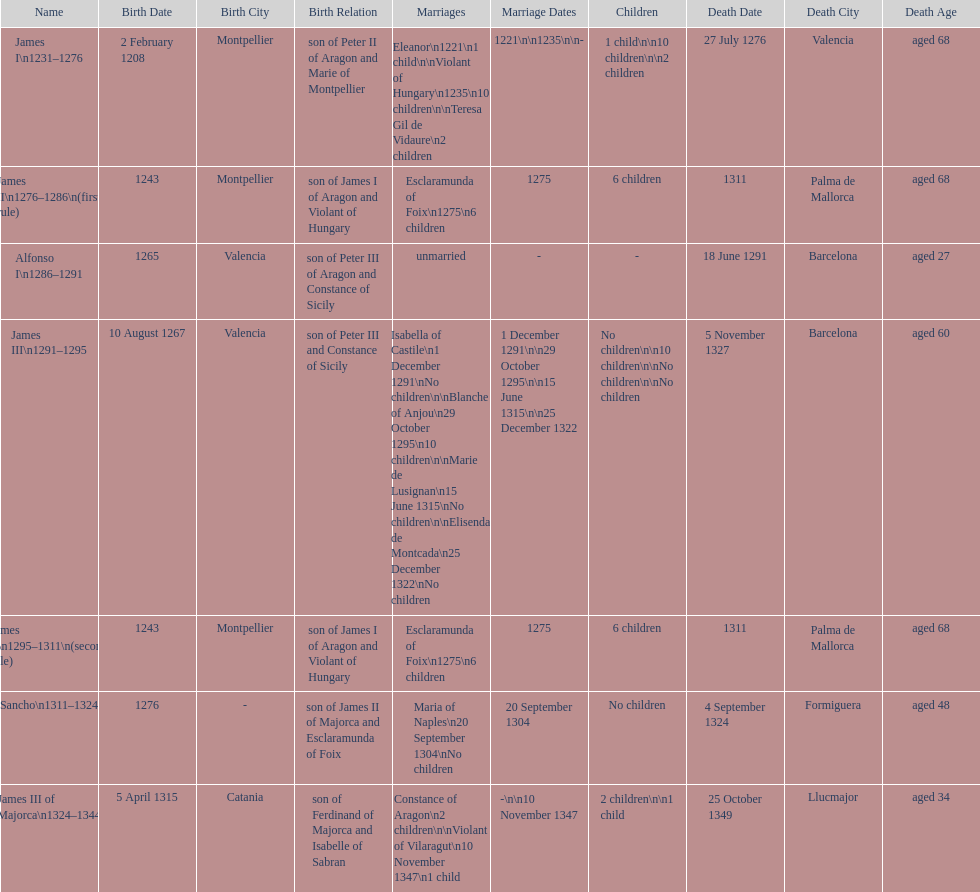What name is above james iii and below james ii? Alfonso I. Can you give me this table as a dict? {'header': ['Name', 'Birth Date', 'Birth City', 'Birth Relation', 'Marriages', 'Marriage Dates', 'Children', 'Death Date', 'Death City', 'Death Age'], 'rows': [['James I\\n1231–1276', '2 February 1208', 'Montpellier', 'son of Peter II of Aragon and Marie of Montpellier', 'Eleanor\\n1221\\n1 child\\n\\nViolant of Hungary\\n1235\\n10 children\\n\\nTeresa Gil de Vidaure\\n2 children', '1221\\n\\n1235\\n\\n-', '1 child\\n\\n10 children\\n\\n2 children', '27 July 1276', 'Valencia', 'aged 68'], ['James II\\n1276–1286\\n(first rule)', '1243', 'Montpellier', 'son of James I of Aragon and Violant of Hungary', 'Esclaramunda of Foix\\n1275\\n6 children', '1275', '6 children', '1311', 'Palma de Mallorca', 'aged 68'], ['Alfonso I\\n1286–1291', '1265', 'Valencia', 'son of Peter III of Aragon and Constance of Sicily', 'unmarried', '-', '-', '18 June 1291', 'Barcelona', 'aged 27'], ['James III\\n1291–1295', '10 August 1267', 'Valencia', 'son of Peter III and Constance of Sicily', 'Isabella of Castile\\n1 December 1291\\nNo children\\n\\nBlanche of Anjou\\n29 October 1295\\n10 children\\n\\nMarie de Lusignan\\n15 June 1315\\nNo children\\n\\nElisenda de Montcada\\n25 December 1322\\nNo children', '1 December 1291\\n\\n29 October 1295\\n\\n15 June 1315\\n\\n25 December 1322', 'No children\\n\\n10 children\\n\\nNo children\\n\\nNo children', '5 November 1327', 'Barcelona', 'aged 60'], ['James II\\n1295–1311\\n(second rule)', '1243', 'Montpellier', 'son of James I of Aragon and Violant of Hungary', 'Esclaramunda of Foix\\n1275\\n6 children', '1275', '6 children', '1311', 'Palma de Mallorca', 'aged 68'], ['Sancho\\n1311–1324', '1276', '-', 'son of James II of Majorca and Esclaramunda of Foix', 'Maria of Naples\\n20 September 1304\\nNo children', '20 September 1304', 'No children', '4 September 1324', 'Formiguera', 'aged 48'], ['James III of Majorca\\n1324–1344', '5 April 1315', 'Catania', 'son of Ferdinand of Majorca and Isabelle of Sabran', 'Constance of Aragon\\n2 children\\n\\nViolant of Vilaragut\\n10 November 1347\\n1 child', '-\\n\\n10 November 1347', '2 children\\n\\n1 child', '25 October 1349', 'Llucmajor', 'aged 34']]} 